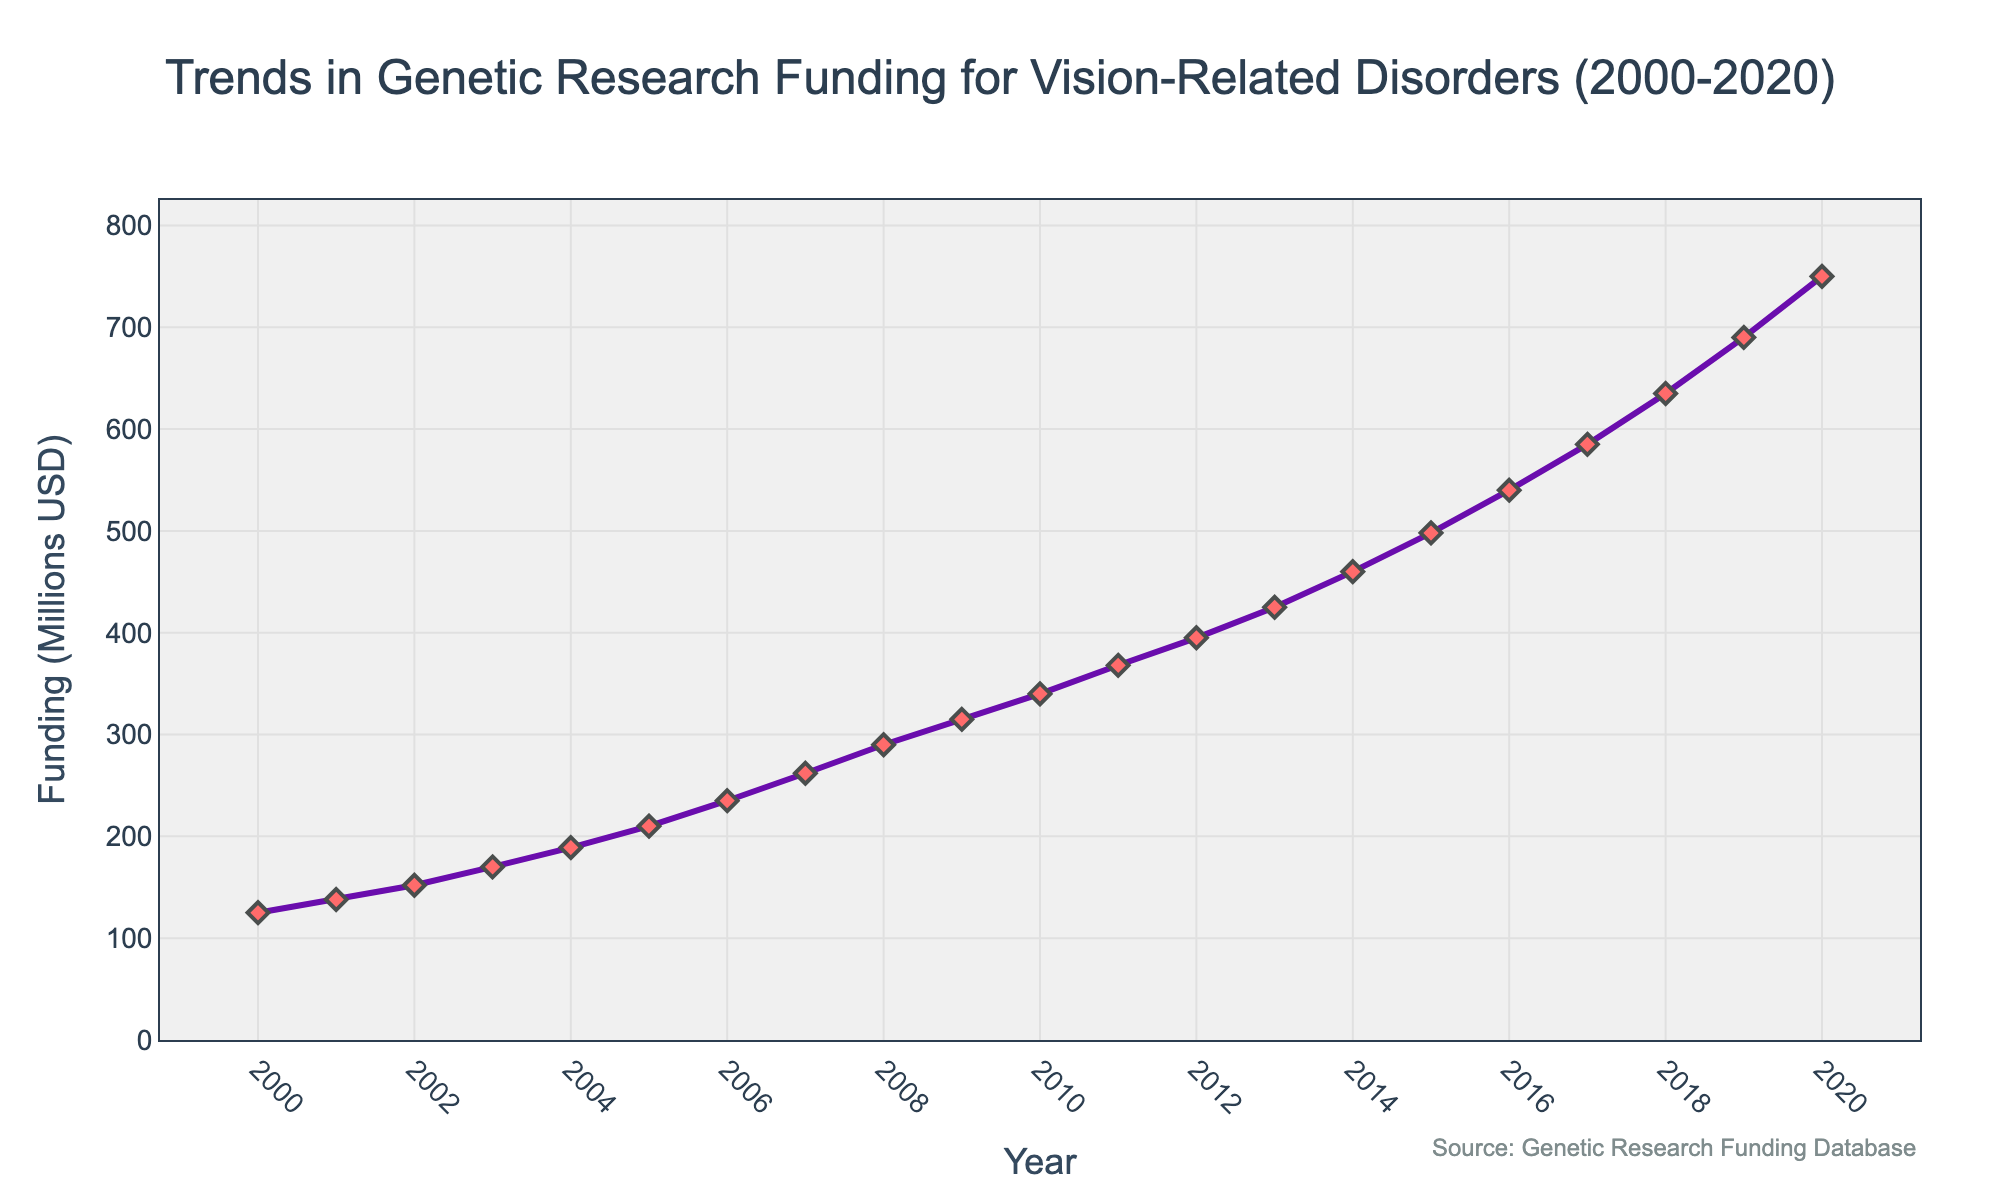What is the overall trend in funding for genetic research on vision-related disorders between 2000 and 2020? The plot shows a consistent upward trend in funding from 2000 to 2020, indicating a steady increase in investment over the years. The line moves continuously upward without any significant declines.
Answer: Increasing Which year had the highest funding for genetic research on vision-related disorders? The highest point on the line plot corresponds to the year 2020, where funding reached its peak. This is visually the tallest point on the line.
Answer: 2020 How much did the funding increase between 2000 and 2020? The funding in 2000 was 125 million USD and in 2020 it was 750 million USD. The difference is calculated as 750 - 125.
Answer: 625 million USD By how much did the funding increase from 2005 to 2006? The funding in 2005 was 210 million USD and in 2006 it was 235 million USD. The increase is calculated as 235 - 210.
Answer: 25 million USD What was the compound annual growth rate (CAGR) of the funding from 2000 to 2020? The CAGR formula is (End Value / Start Value)^(1 / Number of Years) - 1. Using the funding values from 2000 to 2020, the calculation is (750 / 125)^(1 / 20) - 1. Detailed calculations: (750/125) = 6, (6)^(1/20) ≈ 1.095, 1.095 - 1 = 0.095 or 9.5%.
Answer: 9.5% How many years did it take for the funding to double from any given year in the plot? To find when the funding doubled for the first time, we can observe the figure and compare each year's funding to see when it is approximately twice the funding amount of the previous years. It started at 125 million USD in 2000 and reached around 250 million USD in 2006.
Answer: 6 years In which period did the funding see the most rapid increase? By examining the slopes of the line segments, the steepest slope (most rapid increase) occurs between 2015 and 2020, where the funding increased significantly from 498 to 750 million USD.
Answer: 2015-2020 How does the funding in 2010 compare to the funding in 2015? The funding in 2010 was 340 million USD and in 2015 it was 498 million USD. Comparing these values, it shows that the funding in 2015 was greater than in 2010.
Answer: 2015 > 2010 What is the average annual funding from 2000 to 2020? Sum the funding amounts from each year and divide by the number of years. Sum = 125 + 138 + 152 + 170 + 189 + 210 + 235 + 262 + 290 + 315 + 340 + 368 + 395 + 425 + 460 + 498 + 540 + 585 + 635 + 690 + 750. Total sum = 8,327 million USD. Average = 8,327 / 21.
Answer: ~396 million USD Which year had the smallest increase in funding compared to the previous year? By calculating the year-over-year increases and comparing them, the smallest increase occurred between 2001 and 2002, where the funding rose from 138 to 152 million USD, an increase of only 14 million USD.
Answer: 2001-2002 